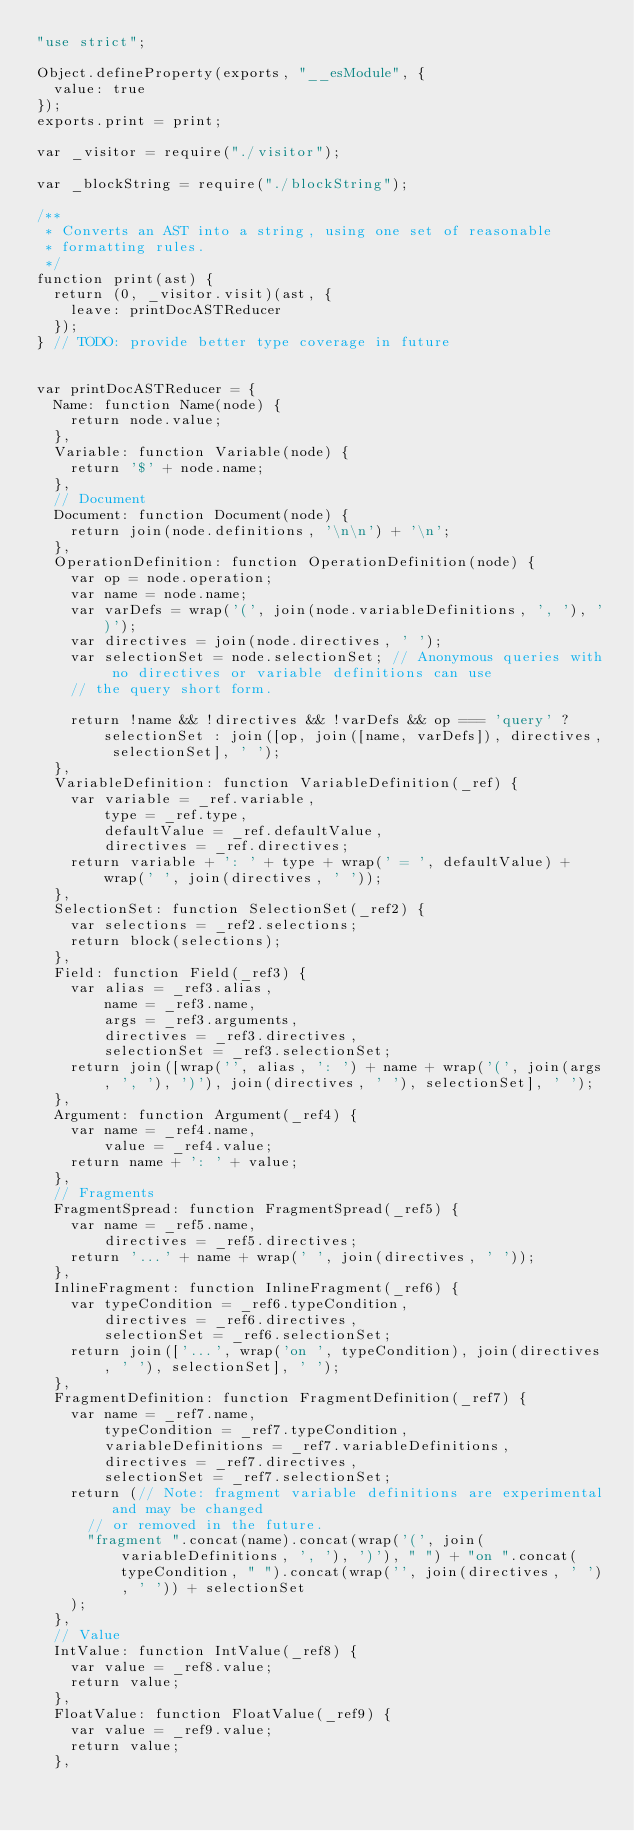<code> <loc_0><loc_0><loc_500><loc_500><_JavaScript_>"use strict";

Object.defineProperty(exports, "__esModule", {
  value: true
});
exports.print = print;

var _visitor = require("./visitor");

var _blockString = require("./blockString");

/**
 * Converts an AST into a string, using one set of reasonable
 * formatting rules.
 */
function print(ast) {
  return (0, _visitor.visit)(ast, {
    leave: printDocASTReducer
  });
} // TODO: provide better type coverage in future


var printDocASTReducer = {
  Name: function Name(node) {
    return node.value;
  },
  Variable: function Variable(node) {
    return '$' + node.name;
  },
  // Document
  Document: function Document(node) {
    return join(node.definitions, '\n\n') + '\n';
  },
  OperationDefinition: function OperationDefinition(node) {
    var op = node.operation;
    var name = node.name;
    var varDefs = wrap('(', join(node.variableDefinitions, ', '), ')');
    var directives = join(node.directives, ' ');
    var selectionSet = node.selectionSet; // Anonymous queries with no directives or variable definitions can use
    // the query short form.

    return !name && !directives && !varDefs && op === 'query' ? selectionSet : join([op, join([name, varDefs]), directives, selectionSet], ' ');
  },
  VariableDefinition: function VariableDefinition(_ref) {
    var variable = _ref.variable,
        type = _ref.type,
        defaultValue = _ref.defaultValue,
        directives = _ref.directives;
    return variable + ': ' + type + wrap(' = ', defaultValue) + wrap(' ', join(directives, ' '));
  },
  SelectionSet: function SelectionSet(_ref2) {
    var selections = _ref2.selections;
    return block(selections);
  },
  Field: function Field(_ref3) {
    var alias = _ref3.alias,
        name = _ref3.name,
        args = _ref3.arguments,
        directives = _ref3.directives,
        selectionSet = _ref3.selectionSet;
    return join([wrap('', alias, ': ') + name + wrap('(', join(args, ', '), ')'), join(directives, ' '), selectionSet], ' ');
  },
  Argument: function Argument(_ref4) {
    var name = _ref4.name,
        value = _ref4.value;
    return name + ': ' + value;
  },
  // Fragments
  FragmentSpread: function FragmentSpread(_ref5) {
    var name = _ref5.name,
        directives = _ref5.directives;
    return '...' + name + wrap(' ', join(directives, ' '));
  },
  InlineFragment: function InlineFragment(_ref6) {
    var typeCondition = _ref6.typeCondition,
        directives = _ref6.directives,
        selectionSet = _ref6.selectionSet;
    return join(['...', wrap('on ', typeCondition), join(directives, ' '), selectionSet], ' ');
  },
  FragmentDefinition: function FragmentDefinition(_ref7) {
    var name = _ref7.name,
        typeCondition = _ref7.typeCondition,
        variableDefinitions = _ref7.variableDefinitions,
        directives = _ref7.directives,
        selectionSet = _ref7.selectionSet;
    return (// Note: fragment variable definitions are experimental and may be changed
      // or removed in the future.
      "fragment ".concat(name).concat(wrap('(', join(variableDefinitions, ', '), ')'), " ") + "on ".concat(typeCondition, " ").concat(wrap('', join(directives, ' '), ' ')) + selectionSet
    );
  },
  // Value
  IntValue: function IntValue(_ref8) {
    var value = _ref8.value;
    return value;
  },
  FloatValue: function FloatValue(_ref9) {
    var value = _ref9.value;
    return value;
  },</code> 